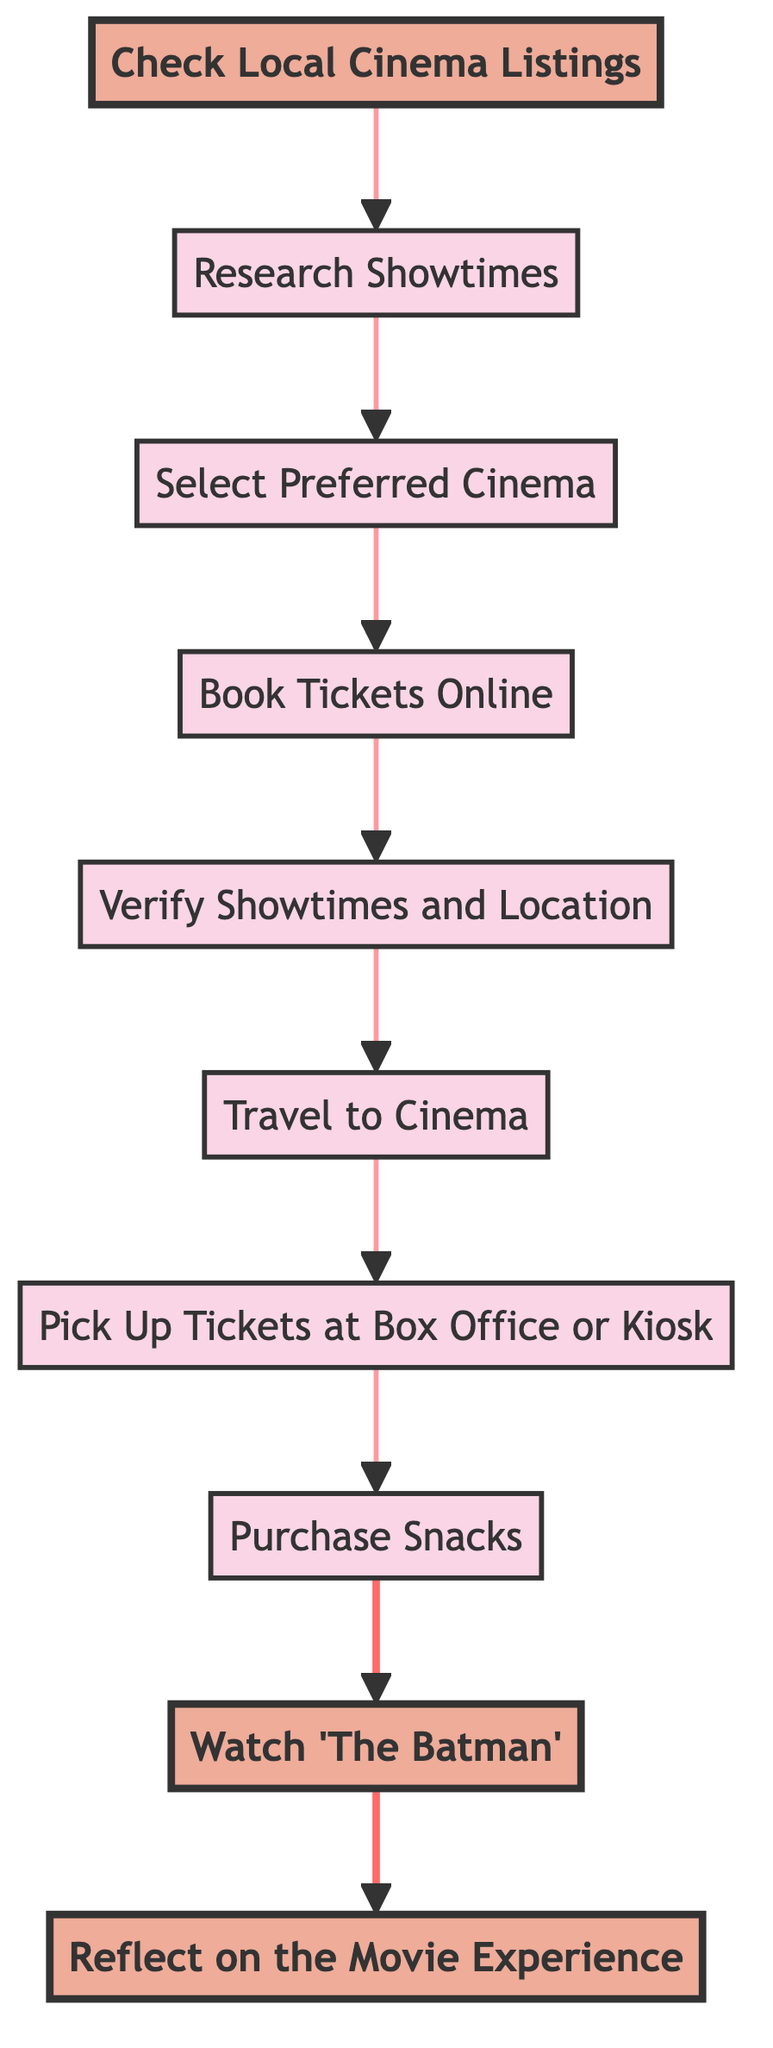What is the first step in the flow? The flow starts with "Check Local Cinema Listings," as it is the initial node in the diagram.
Answer: Check Local Cinema Listings How many nodes are in the flowchart? By counting all the distinct steps listed in the flowchart, there are a total of 10 nodes from "Check Local Cinema Listings" to "Reflect on the Movie Experience."
Answer: 10 Which node comes immediately after "Select Preferred Cinema"? After "Select Preferred Cinema," the next step in the flowchart is "Book Tickets Online," as shown by the directed arrow between the two nodes.
Answer: Book Tickets Online What is the last step after watching 'The Batman'? The final step in the flow is "Reflect on the Movie Experience," which requires thinking back on the movie after it's been watched.
Answer: Reflect on the Movie Experience What nodes are connected by the edge from "Book Tickets Online"? The edge from "Book Tickets Online" leads to "Verify Showtimes and Location," following the directional flow of the process.
Answer: Verify Showtimes and Location What should you do after verifying showtimes and location? Following the flow, after verifying showtimes and location, the next action is to "Travel to Cinema." This is the step that comes directly after in the sequence.
Answer: Travel to Cinema What are the two emphasized nodes in the diagram? The emphasized nodes are "Check Local Cinema Listings" and "Watch 'The Batman'," which stand out from the rest due to their unique styling.
Answer: Check Local Cinema Listings, Watch 'The Batman' How does the flowchart represent the relationship between "Travel to Cinema" and "Pick Up Tickets at Box Office or Kiosk"? There is a directed arrow from "Travel to Cinema" pointing to "Pick Up Tickets at Box Office or Kiosk," indicating the flow progresses in this specific order after traveling to the cinema.
Answer: Directed arrow What flows directly into "Purchase Snacks"? "Pick Up Tickets at Box Office or Kiosk" directly flows into "Purchase Snacks," which indicates that one must pick up tickets before proceeding to buy snacks.
Answer: Pick Up Tickets at Box Office or Kiosk 